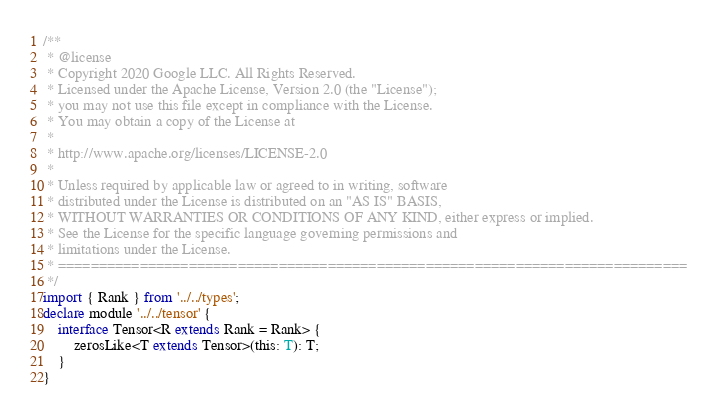<code> <loc_0><loc_0><loc_500><loc_500><_TypeScript_>/**
 * @license
 * Copyright 2020 Google LLC. All Rights Reserved.
 * Licensed under the Apache License, Version 2.0 (the "License");
 * you may not use this file except in compliance with the License.
 * You may obtain a copy of the License at
 *
 * http://www.apache.org/licenses/LICENSE-2.0
 *
 * Unless required by applicable law or agreed to in writing, software
 * distributed under the License is distributed on an "AS IS" BASIS,
 * WITHOUT WARRANTIES OR CONDITIONS OF ANY KIND, either express or implied.
 * See the License for the specific language governing permissions and
 * limitations under the License.
 * =============================================================================
 */
import { Rank } from '../../types';
declare module '../../tensor' {
    interface Tensor<R extends Rank = Rank> {
        zerosLike<T extends Tensor>(this: T): T;
    }
}
</code> 